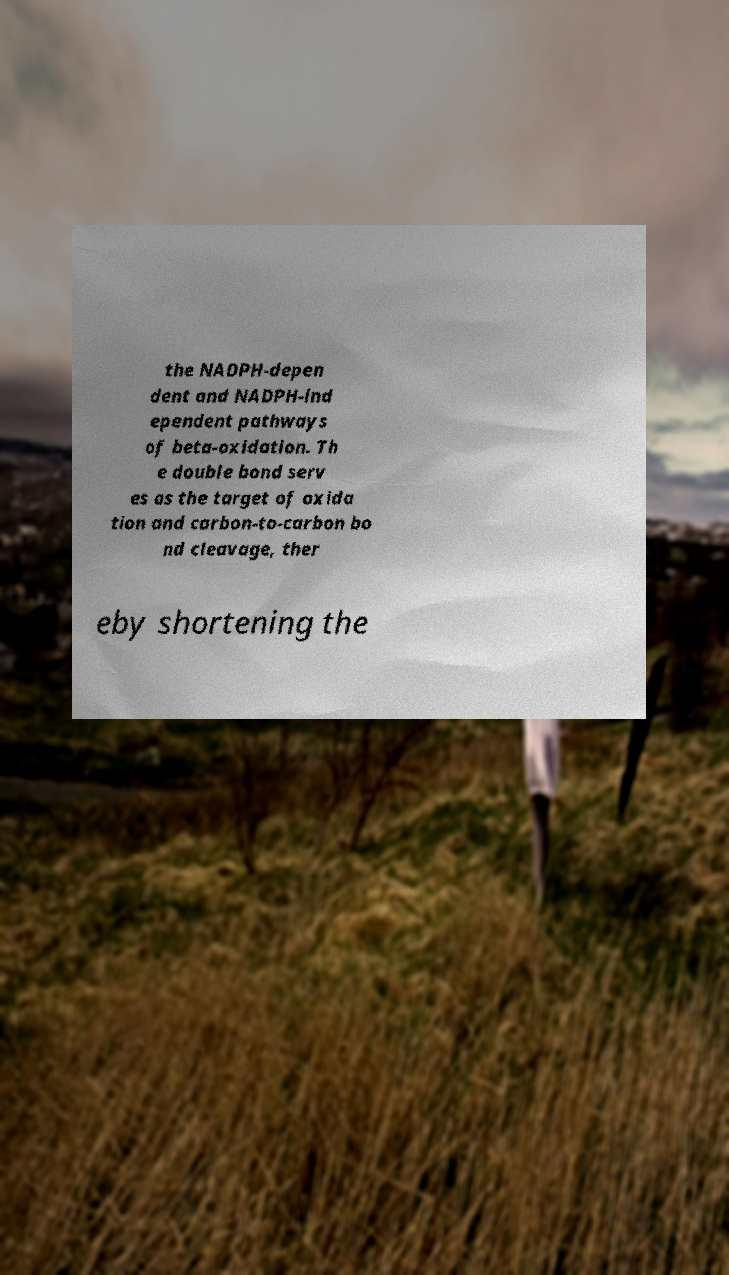Please identify and transcribe the text found in this image. the NADPH-depen dent and NADPH-ind ependent pathways of beta-oxidation. Th e double bond serv es as the target of oxida tion and carbon-to-carbon bo nd cleavage, ther eby shortening the 